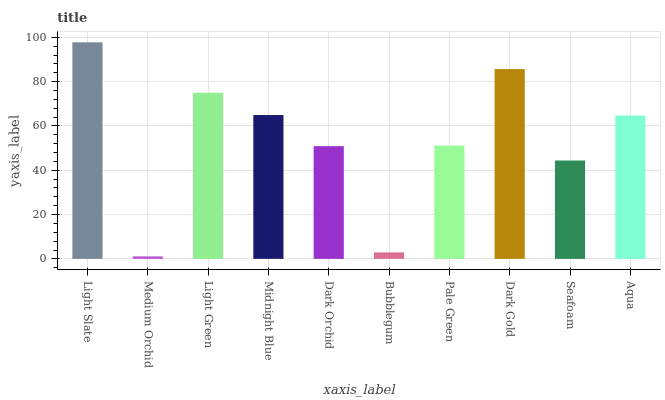Is Medium Orchid the minimum?
Answer yes or no. Yes. Is Light Slate the maximum?
Answer yes or no. Yes. Is Light Green the minimum?
Answer yes or no. No. Is Light Green the maximum?
Answer yes or no. No. Is Light Green greater than Medium Orchid?
Answer yes or no. Yes. Is Medium Orchid less than Light Green?
Answer yes or no. Yes. Is Medium Orchid greater than Light Green?
Answer yes or no. No. Is Light Green less than Medium Orchid?
Answer yes or no. No. Is Aqua the high median?
Answer yes or no. Yes. Is Pale Green the low median?
Answer yes or no. Yes. Is Dark Orchid the high median?
Answer yes or no. No. Is Dark Orchid the low median?
Answer yes or no. No. 